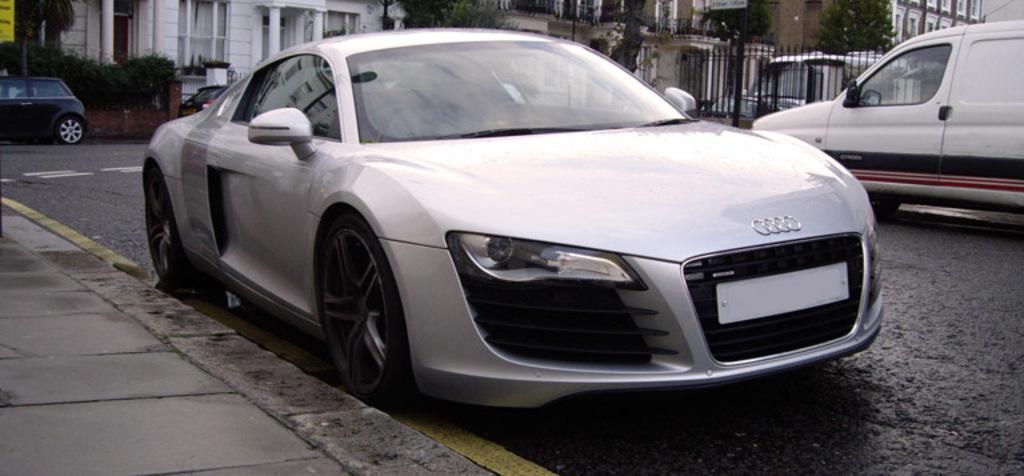In one or two sentences, can you explain what this image depicts? In this image there are cars on the road, and in the background there are iron grills, trees, buildings. 